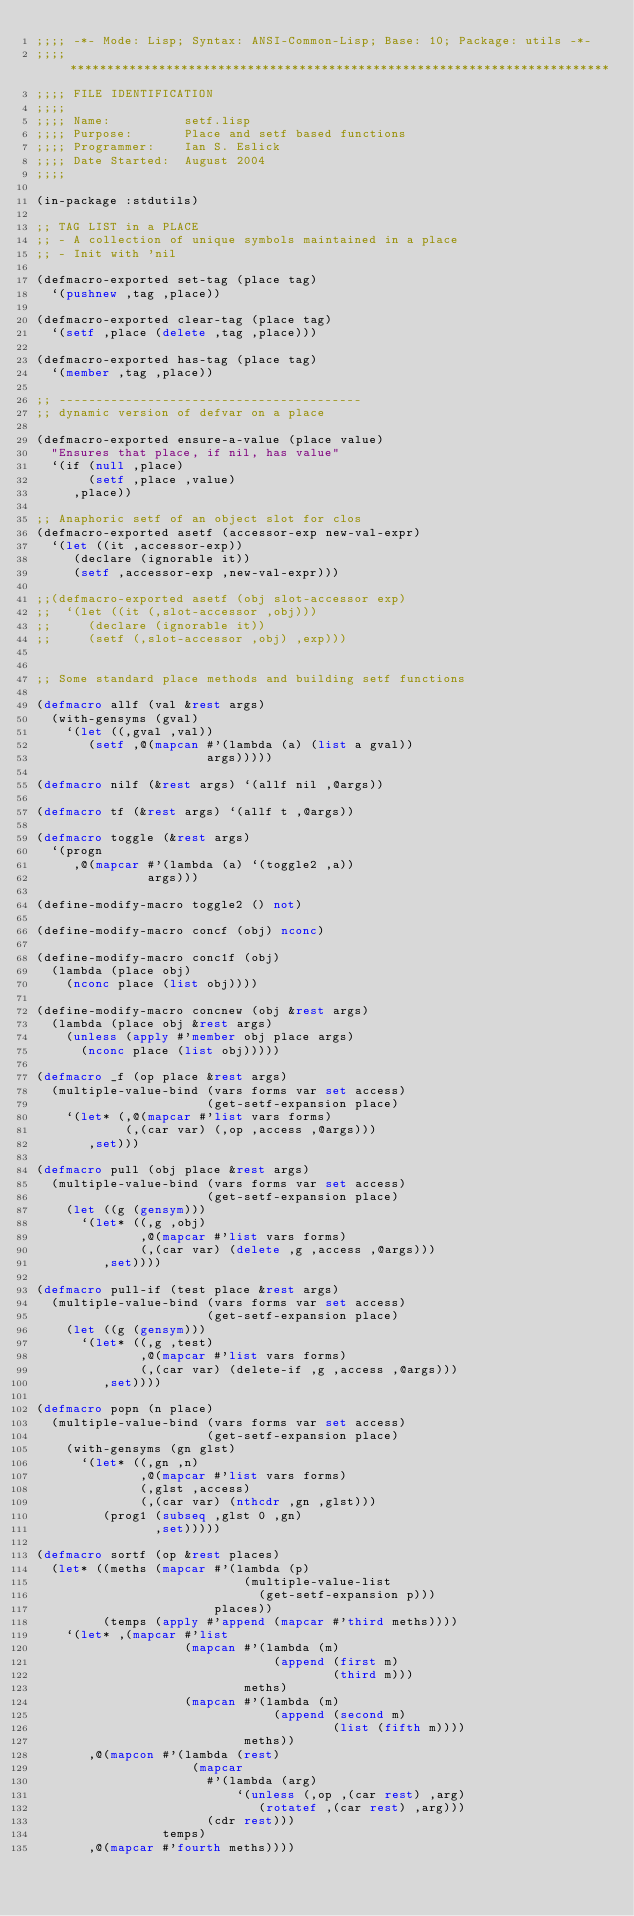<code> <loc_0><loc_0><loc_500><loc_500><_Lisp_>;;;; -*- Mode: Lisp; Syntax: ANSI-Common-Lisp; Base: 10; Package: utils -*-
;;;; *************************************************************************
;;;; FILE IDENTIFICATION
;;;;
;;;; Name:          setf.lisp
;;;; Purpose:       Place and setf based functions
;;;; Programmer:    Ian S. Eslick
;;;; Date Started:  August 2004
;;;;

(in-package :stdutils)

;; TAG LIST in a PLACE
;; - A collection of unique symbols maintained in a place
;; - Init with 'nil

(defmacro-exported set-tag (place tag)
  `(pushnew ,tag ,place))

(defmacro-exported clear-tag (place tag)
  `(setf ,place (delete ,tag ,place)))

(defmacro-exported has-tag (place tag)
  `(member ,tag ,place))

;; -----------------------------------------
;; dynamic version of defvar on a place

(defmacro-exported ensure-a-value (place value)
  "Ensures that place, if nil, has value"
  `(if (null ,place)
       (setf ,place ,value)
     ,place))

;; Anaphoric setf of an object slot for clos
(defmacro-exported asetf (accessor-exp new-val-expr)
  `(let ((it ,accessor-exp))
     (declare (ignorable it))
     (setf ,accessor-exp ,new-val-expr)))

;;(defmacro-exported asetf (obj slot-accessor exp)
;;  `(let ((it (,slot-accessor ,obj)))
;;     (declare (ignorable it))
;;     (setf (,slot-accessor ,obj) ,exp)))


;; Some standard place methods and building setf functions

(defmacro allf (val &rest args)
  (with-gensyms (gval)
    `(let ((,gval ,val))
       (setf ,@(mapcan #'(lambda (a) (list a gval))
                       args)))))

(defmacro nilf (&rest args) `(allf nil ,@args))

(defmacro tf (&rest args) `(allf t ,@args))

(defmacro toggle (&rest args)
  `(progn
     ,@(mapcar #'(lambda (a) `(toggle2 ,a))
               args)))

(define-modify-macro toggle2 () not)

(define-modify-macro concf (obj) nconc)

(define-modify-macro conc1f (obj) 
  (lambda (place obj)
    (nconc place (list obj))))

(define-modify-macro concnew (obj &rest args)
  (lambda (place obj &rest args)
    (unless (apply #'member obj place args)
      (nconc place (list obj)))))

(defmacro _f (op place &rest args)
  (multiple-value-bind (vars forms var set access) 
                       (get-setf-expansion place)
    `(let* (,@(mapcar #'list vars forms)
            (,(car var) (,op ,access ,@args)))
       ,set)))

(defmacro pull (obj place &rest args)
  (multiple-value-bind (vars forms var set access)
                       (get-setf-expansion place)
    (let ((g (gensym)))
      `(let* ((,g ,obj)
              ,@(mapcar #'list vars forms)
              (,(car var) (delete ,g ,access ,@args)))
         ,set))))

(defmacro pull-if (test place &rest args) 
  (multiple-value-bind (vars forms var set access) 
                       (get-setf-expansion place) 
    (let ((g (gensym))) 
      `(let* ((,g ,test) 
              ,@(mapcar #'list vars forms) 
              (,(car var) (delete-if ,g ,access ,@args))) 
         ,set)))) 

(defmacro popn (n place) 
  (multiple-value-bind (vars forms var set access) 
                       (get-setf-expansion place) 
    (with-gensyms (gn glst)
      `(let* ((,gn ,n)
              ,@(mapcar #'list vars forms)
              (,glst ,access)
              (,(car var) (nthcdr ,gn ,glst)))
         (prog1 (subseq ,glst 0 ,gn)
                ,set)))))

(defmacro sortf (op &rest places)
  (let* ((meths (mapcar #'(lambda (p)
                            (multiple-value-list 
                              (get-setf-expansion p)))
                        places))
         (temps (apply #'append (mapcar #'third meths))))
    `(let* ,(mapcar #'list
                    (mapcan #'(lambda (m)
                                (append (first m) 
                                        (third m)))
                            meths)
                    (mapcan #'(lambda (m)
                                (append (second m) 
                                        (list (fifth m))))
                            meths))
       ,@(mapcon #'(lambda (rest)
                     (mapcar 
                       #'(lambda (arg)
                           `(unless (,op ,(car rest) ,arg)
                              (rotatef ,(car rest) ,arg)))
                       (cdr rest)))
                 temps)
       ,@(mapcar #'fourth meths))))

</code> 